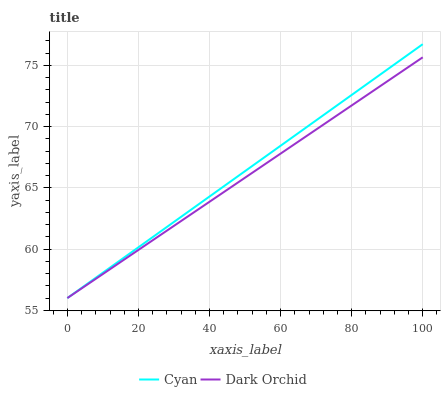Does Dark Orchid have the minimum area under the curve?
Answer yes or no. Yes. Does Cyan have the maximum area under the curve?
Answer yes or no. Yes. Does Dark Orchid have the maximum area under the curve?
Answer yes or no. No. Is Dark Orchid the smoothest?
Answer yes or no. Yes. Is Cyan the roughest?
Answer yes or no. Yes. Is Dark Orchid the roughest?
Answer yes or no. No. Does Cyan have the lowest value?
Answer yes or no. Yes. Does Cyan have the highest value?
Answer yes or no. Yes. Does Dark Orchid have the highest value?
Answer yes or no. No. Does Dark Orchid intersect Cyan?
Answer yes or no. Yes. Is Dark Orchid less than Cyan?
Answer yes or no. No. Is Dark Orchid greater than Cyan?
Answer yes or no. No. 